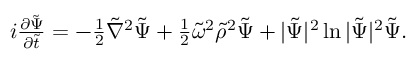Convert formula to latex. <formula><loc_0><loc_0><loc_500><loc_500>\begin{array} { r } { i \frac { \partial { \tilde { \Psi } } } { \partial \tilde { t } } = - \frac { 1 } { 2 } { \tilde { \nabla } } ^ { 2 } { \tilde { \Psi } } + \frac { 1 } { 2 } { \tilde { \omega } } ^ { 2 } { \tilde { \rho } } ^ { 2 } { \tilde { \Psi } } + | { \tilde { \Psi } } | ^ { 2 } \ln | { \tilde { \Psi } } | ^ { 2 } { \tilde { \Psi } } . } \end{array}</formula> 